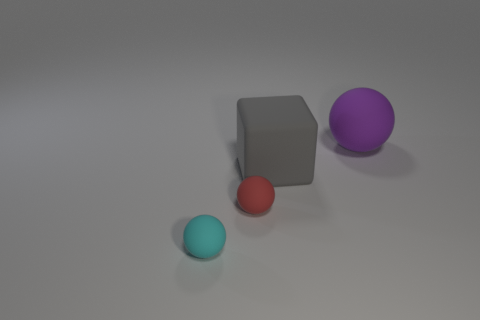Subtract all brown spheres. Subtract all blue cubes. How many spheres are left? 3 Add 4 big brown rubber cylinders. How many objects exist? 8 Subtract all cubes. How many objects are left? 3 Subtract 0 red cubes. How many objects are left? 4 Subtract all cyan metallic things. Subtract all gray matte objects. How many objects are left? 3 Add 1 matte spheres. How many matte spheres are left? 4 Add 3 large purple balls. How many large purple balls exist? 4 